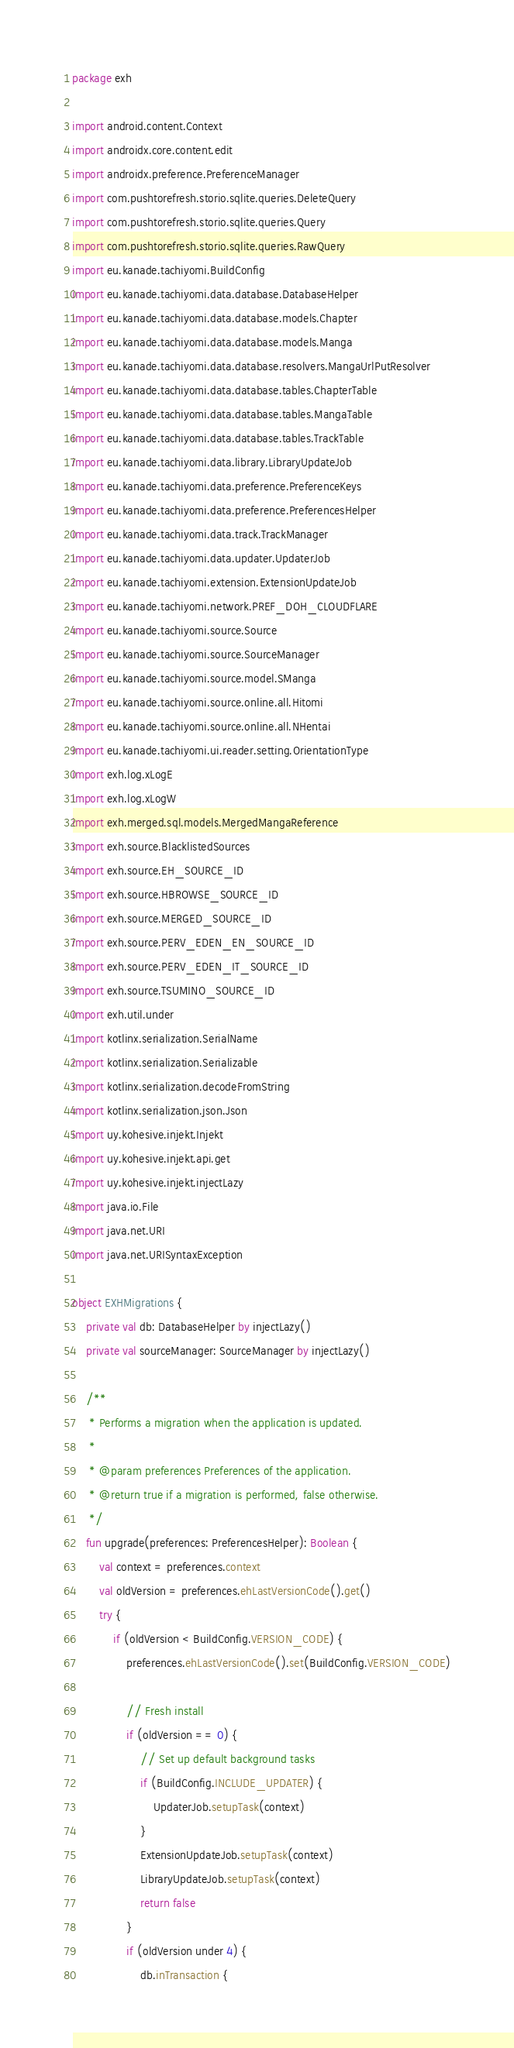<code> <loc_0><loc_0><loc_500><loc_500><_Kotlin_>package exh

import android.content.Context
import androidx.core.content.edit
import androidx.preference.PreferenceManager
import com.pushtorefresh.storio.sqlite.queries.DeleteQuery
import com.pushtorefresh.storio.sqlite.queries.Query
import com.pushtorefresh.storio.sqlite.queries.RawQuery
import eu.kanade.tachiyomi.BuildConfig
import eu.kanade.tachiyomi.data.database.DatabaseHelper
import eu.kanade.tachiyomi.data.database.models.Chapter
import eu.kanade.tachiyomi.data.database.models.Manga
import eu.kanade.tachiyomi.data.database.resolvers.MangaUrlPutResolver
import eu.kanade.tachiyomi.data.database.tables.ChapterTable
import eu.kanade.tachiyomi.data.database.tables.MangaTable
import eu.kanade.tachiyomi.data.database.tables.TrackTable
import eu.kanade.tachiyomi.data.library.LibraryUpdateJob
import eu.kanade.tachiyomi.data.preference.PreferenceKeys
import eu.kanade.tachiyomi.data.preference.PreferencesHelper
import eu.kanade.tachiyomi.data.track.TrackManager
import eu.kanade.tachiyomi.data.updater.UpdaterJob
import eu.kanade.tachiyomi.extension.ExtensionUpdateJob
import eu.kanade.tachiyomi.network.PREF_DOH_CLOUDFLARE
import eu.kanade.tachiyomi.source.Source
import eu.kanade.tachiyomi.source.SourceManager
import eu.kanade.tachiyomi.source.model.SManga
import eu.kanade.tachiyomi.source.online.all.Hitomi
import eu.kanade.tachiyomi.source.online.all.NHentai
import eu.kanade.tachiyomi.ui.reader.setting.OrientationType
import exh.log.xLogE
import exh.log.xLogW
import exh.merged.sql.models.MergedMangaReference
import exh.source.BlacklistedSources
import exh.source.EH_SOURCE_ID
import exh.source.HBROWSE_SOURCE_ID
import exh.source.MERGED_SOURCE_ID
import exh.source.PERV_EDEN_EN_SOURCE_ID
import exh.source.PERV_EDEN_IT_SOURCE_ID
import exh.source.TSUMINO_SOURCE_ID
import exh.util.under
import kotlinx.serialization.SerialName
import kotlinx.serialization.Serializable
import kotlinx.serialization.decodeFromString
import kotlinx.serialization.json.Json
import uy.kohesive.injekt.Injekt
import uy.kohesive.injekt.api.get
import uy.kohesive.injekt.injectLazy
import java.io.File
import java.net.URI
import java.net.URISyntaxException

object EXHMigrations {
    private val db: DatabaseHelper by injectLazy()
    private val sourceManager: SourceManager by injectLazy()

    /**
     * Performs a migration when the application is updated.
     *
     * @param preferences Preferences of the application.
     * @return true if a migration is performed, false otherwise.
     */
    fun upgrade(preferences: PreferencesHelper): Boolean {
        val context = preferences.context
        val oldVersion = preferences.ehLastVersionCode().get()
        try {
            if (oldVersion < BuildConfig.VERSION_CODE) {
                preferences.ehLastVersionCode().set(BuildConfig.VERSION_CODE)

                // Fresh install
                if (oldVersion == 0) {
                    // Set up default background tasks
                    if (BuildConfig.INCLUDE_UPDATER) {
                        UpdaterJob.setupTask(context)
                    }
                    ExtensionUpdateJob.setupTask(context)
                    LibraryUpdateJob.setupTask(context)
                    return false
                }
                if (oldVersion under 4) {
                    db.inTransaction {</code> 